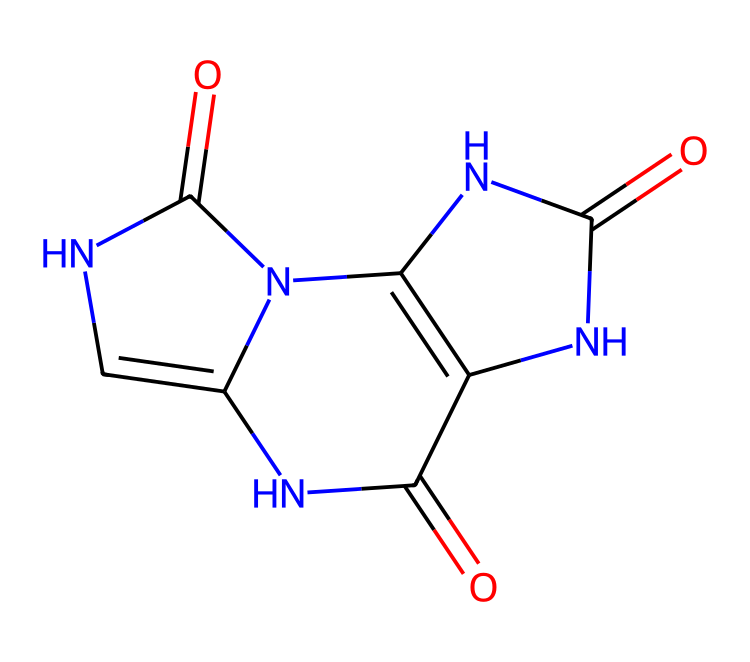What is the main functional group in this chemical? The chemical structure contains several amide (–C(=O)N–) functional groups, identifiable by the carbonyl (C=O) directly linked to a nitrogen atom.
Answer: amide How many nitrogen atoms are present in this chemical? By examining the chemical structure, there are four distinct nitrogen atoms (N) present in the ring and surrounding the carbonyl groups.
Answer: four What type of acid is represented by this chemical? This chemical is uric acid, a type of organic acid specifically noted for its role in the excretion of nitrogen in mammals.
Answer: uric acid Which part of the chemical contributes to its acidity? The carbonyl groups (C=O) attached to the nitrogen atoms are responsible for the acidity due to their ability to donate protons (H+) in a solution.
Answer: carbonyl groups What is the total number of carbon atoms in this chemical structure? Counting the carbon atoms within the ring structure and side chains shows there are five carbon atoms present in this molecule.
Answer: five 